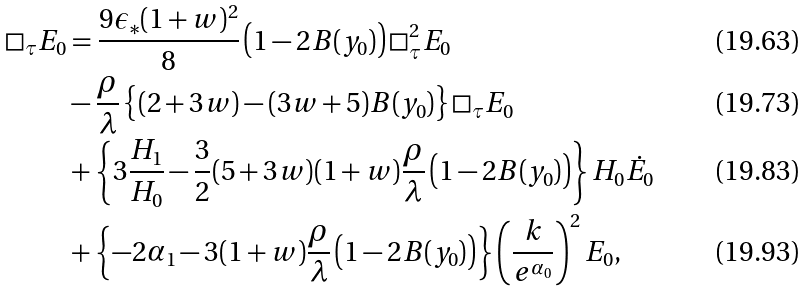Convert formula to latex. <formula><loc_0><loc_0><loc_500><loc_500>\Box _ { \tau } E _ { 0 } & = \frac { 9 \epsilon _ { * } ( 1 + w ) ^ { 2 } } { 8 } \left ( 1 - 2 B ( y _ { 0 } ) \right ) \Box ^ { 2 } _ { \tau } E _ { 0 } \\ & - \frac { \rho } { \lambda } \left \{ ( 2 + 3 w ) - ( 3 w + 5 ) B ( y _ { 0 } ) \right \} \Box _ { \tau } E _ { 0 } \\ & + \left \{ 3 \frac { H _ { 1 } } { H _ { 0 } } - \frac { 3 } { 2 } ( 5 + 3 w ) ( 1 + w ) \frac { \rho } { \lambda } \left ( 1 - 2 B ( y _ { 0 } ) \right ) \right \} H _ { 0 } \dot { E } _ { 0 } \\ & + \left \{ - 2 \alpha _ { 1 } - 3 ( 1 + w ) \frac { \rho } { \lambda } \left ( 1 - 2 B ( y _ { 0 } ) \right ) \right \} \left ( \frac { k } { e ^ { \alpha _ { 0 } } } \right ) ^ { 2 } E _ { 0 } ,</formula> 